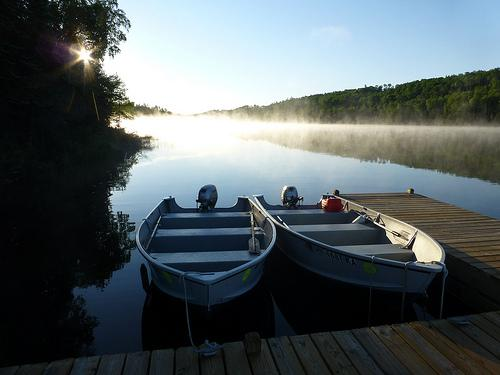Question: what is present?
Choices:
A. Cars.
B. Trains.
C. Trucks.
D. Boats.
Answer with the letter. Answer: D Question: where was this photo taken?
Choices:
A. On the lake.
B. On the ocean.
C. On a river.
D. In a field.
Answer with the letter. Answer: A Question: who is present?
Choices:
A. Man.
B. Nobody.
C. Woman.
D. Boy.
Answer with the letter. Answer: B Question: what are they on?
Choices:
A. Sand.
B. Grass.
C. Ice.
D. Water.
Answer with the letter. Answer: D 